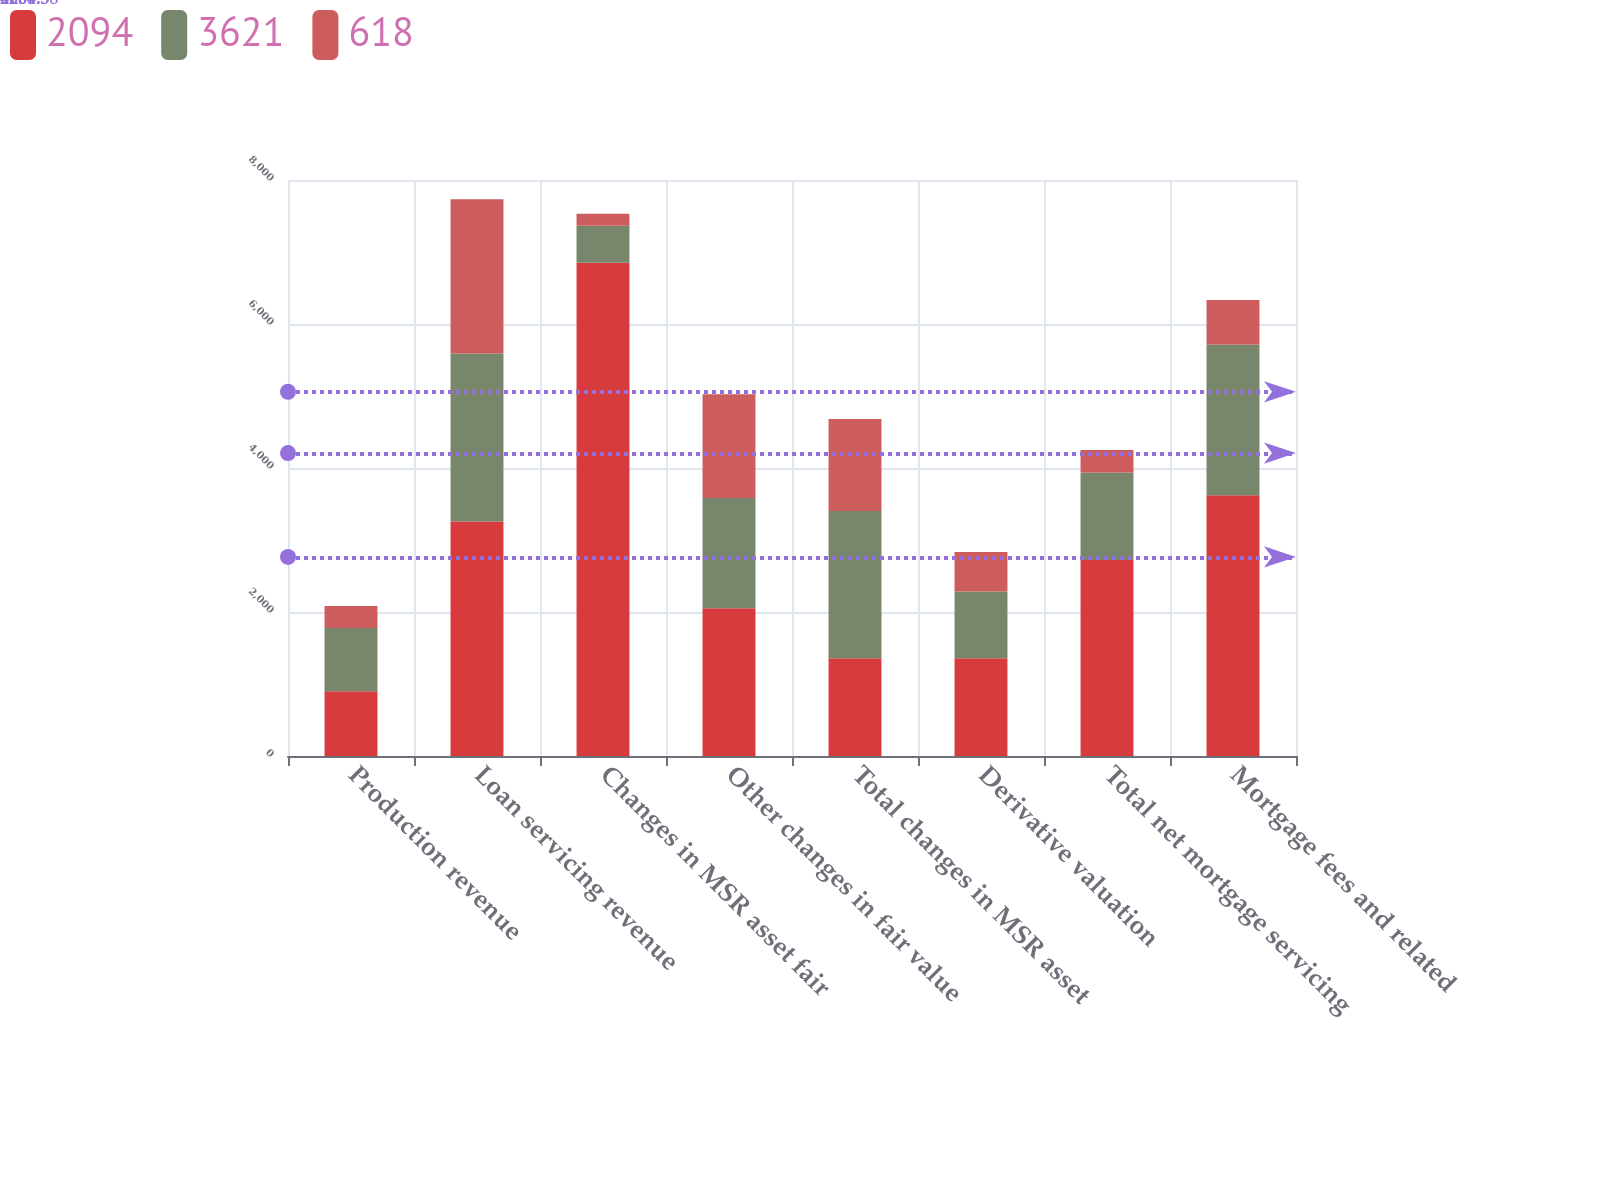<chart> <loc_0><loc_0><loc_500><loc_500><stacked_bar_chart><ecel><fcel>Production revenue<fcel>Loan servicing revenue<fcel>Changes in MSR asset fair<fcel>Other changes in fair value<fcel>Total changes in MSR asset<fcel>Derivative valuation<fcel>Total net mortgage servicing<fcel>Mortgage fees and related<nl><fcel>2094<fcel>898<fcel>3258<fcel>6849<fcel>2052<fcel>1357.5<fcel>1357.5<fcel>2723<fcel>3621<nl><fcel>3621<fcel>880<fcel>2334<fcel>516<fcel>1531<fcel>2047<fcel>927<fcel>1214<fcel>2094<nl><fcel>618<fcel>304<fcel>2139<fcel>165<fcel>1440<fcel>1275<fcel>550<fcel>314<fcel>618<nl></chart> 